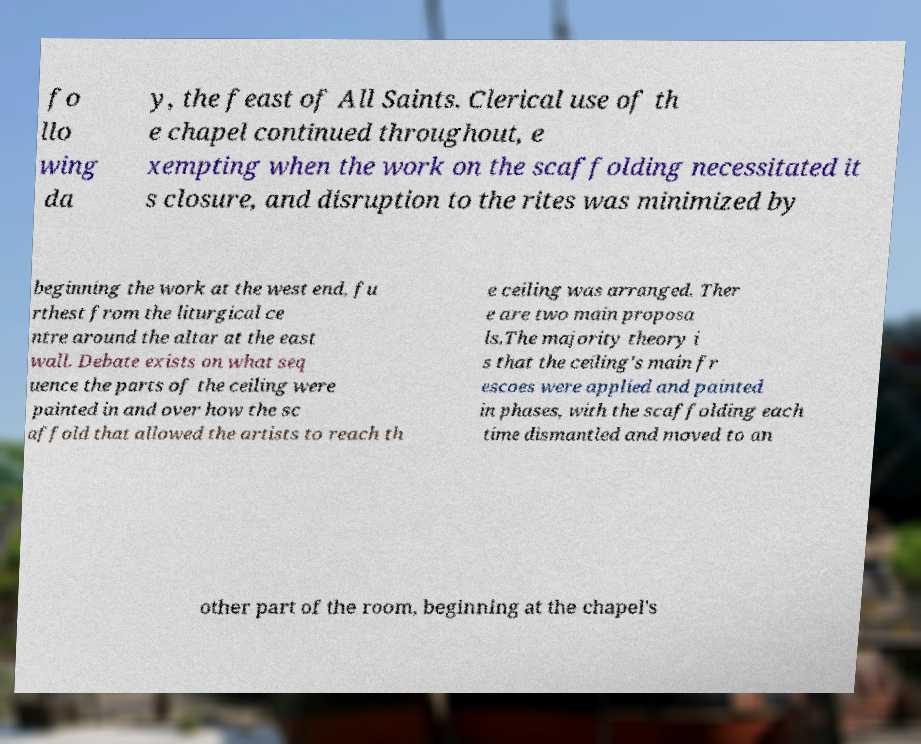There's text embedded in this image that I need extracted. Can you transcribe it verbatim? fo llo wing da y, the feast of All Saints. Clerical use of th e chapel continued throughout, e xempting when the work on the scaffolding necessitated it s closure, and disruption to the rites was minimized by beginning the work at the west end, fu rthest from the liturgical ce ntre around the altar at the east wall. Debate exists on what seq uence the parts of the ceiling were painted in and over how the sc affold that allowed the artists to reach th e ceiling was arranged. Ther e are two main proposa ls.The majority theory i s that the ceiling's main fr escoes were applied and painted in phases, with the scaffolding each time dismantled and moved to an other part of the room, beginning at the chapel's 